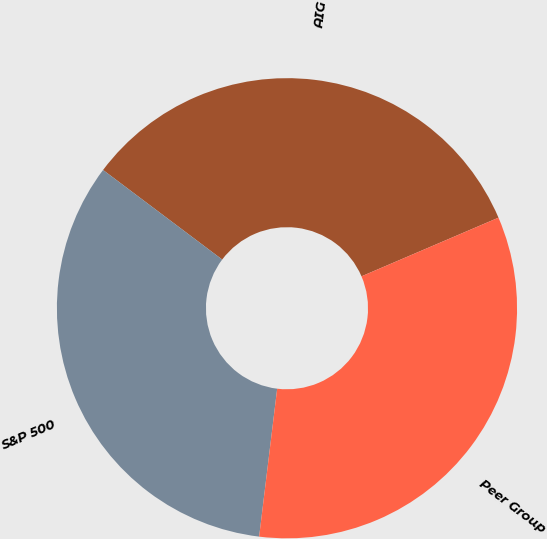Convert chart to OTSL. <chart><loc_0><loc_0><loc_500><loc_500><pie_chart><fcel>AIG<fcel>S&P 500<fcel>Peer Group<nl><fcel>33.3%<fcel>33.33%<fcel>33.37%<nl></chart> 